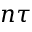<formula> <loc_0><loc_0><loc_500><loc_500>n \tau</formula> 